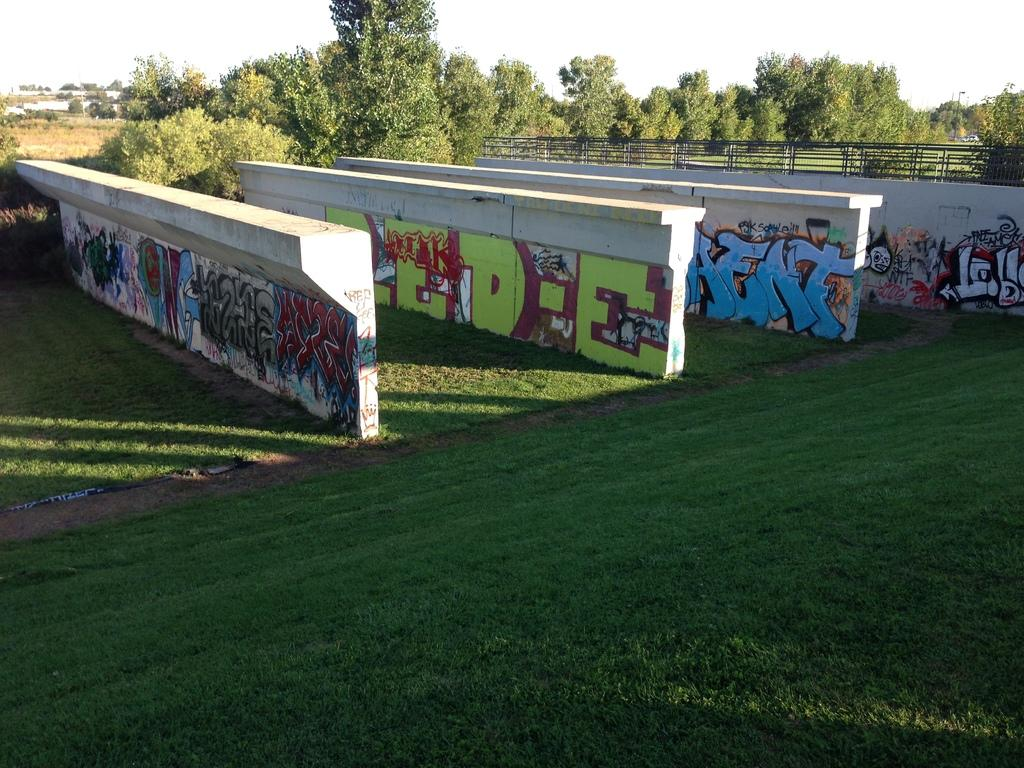What type of structures can be seen in the image? There are walls in the image. What decorations are on the walls? Paintings are present on the walls. What type of vegetation is visible in the image? There is grass visible in the image. What can be seen in the background of the image? There are trees and the sky visible in the background of the image. What type of liquid is being poured from the goose in the image? There is no goose present in the image, and therefore no liquid being poured. 